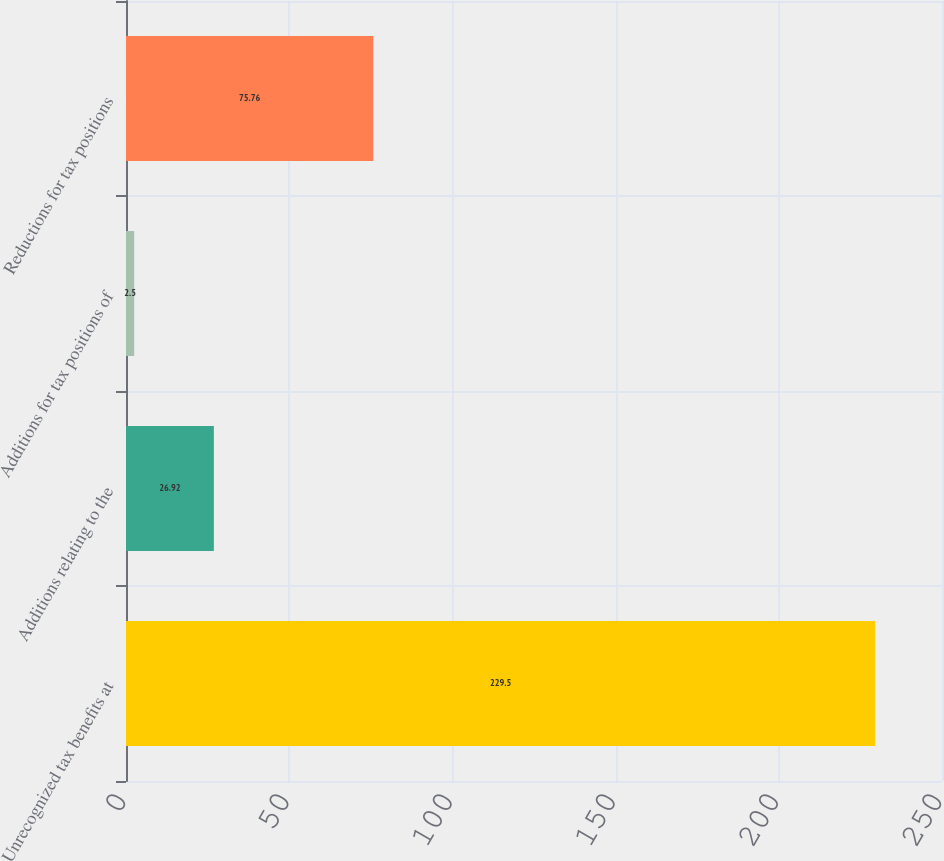Convert chart. <chart><loc_0><loc_0><loc_500><loc_500><bar_chart><fcel>Unrecognized tax benefits at<fcel>Additions relating to the<fcel>Additions for tax positions of<fcel>Reductions for tax positions<nl><fcel>229.5<fcel>26.92<fcel>2.5<fcel>75.76<nl></chart> 